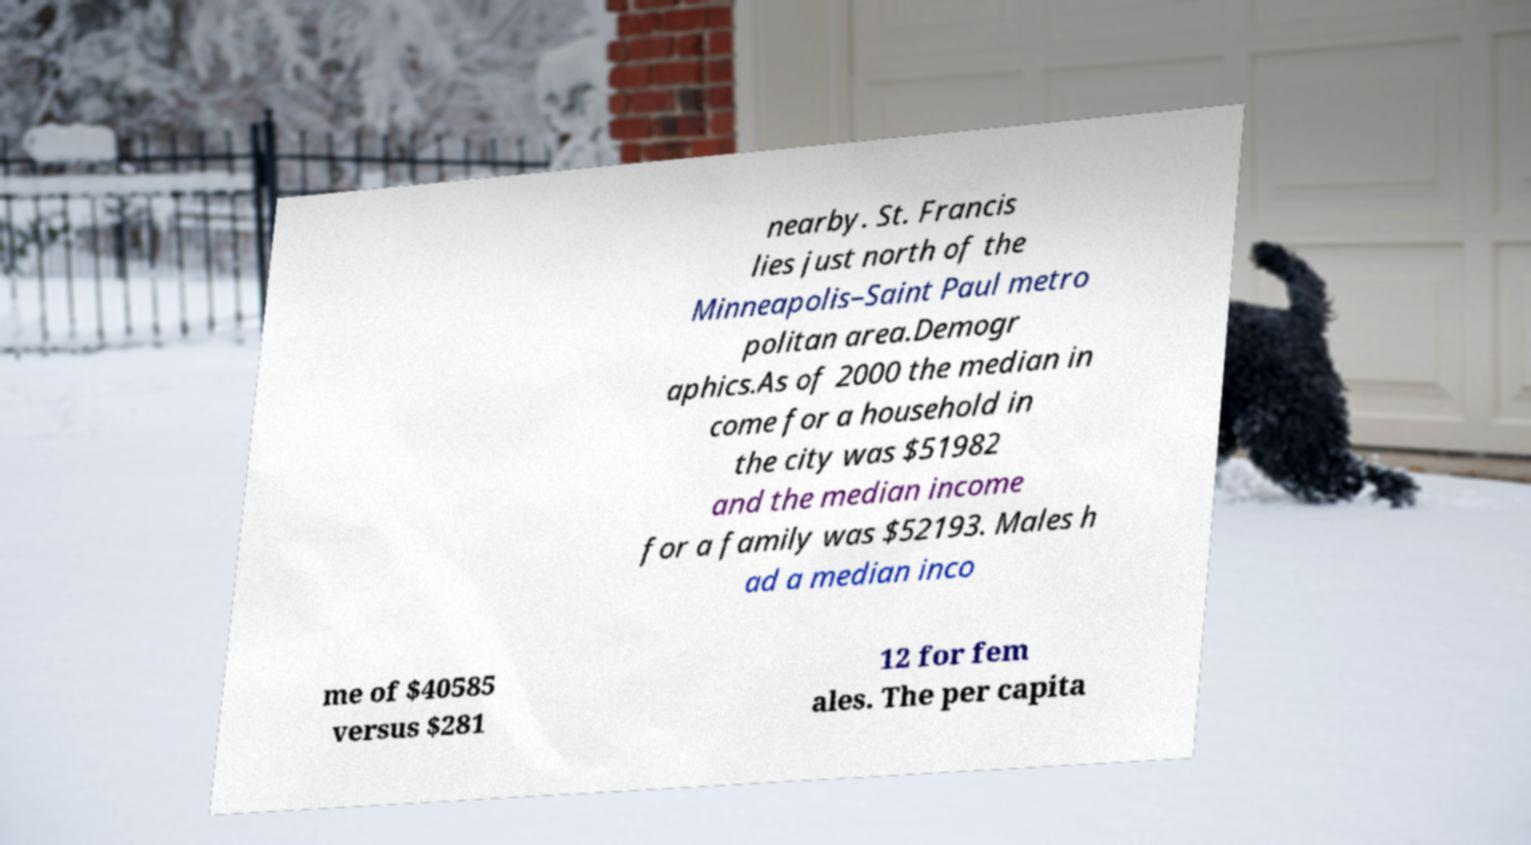Could you extract and type out the text from this image? nearby. St. Francis lies just north of the Minneapolis–Saint Paul metro politan area.Demogr aphics.As of 2000 the median in come for a household in the city was $51982 and the median income for a family was $52193. Males h ad a median inco me of $40585 versus $281 12 for fem ales. The per capita 